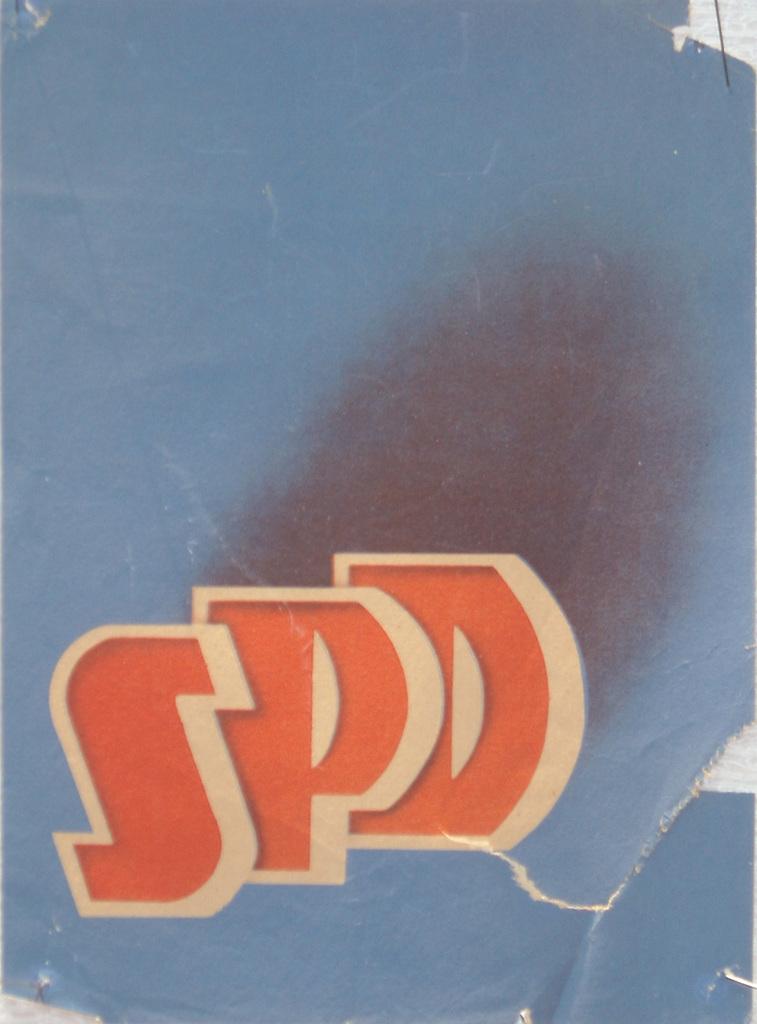What are the 3 letters shown?
Offer a terse response. Spd. What color are the three letters shown?
Make the answer very short. Red. 